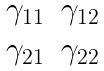<formula> <loc_0><loc_0><loc_500><loc_500>\begin{matrix} \gamma _ { 1 1 } & \gamma _ { 1 2 } \\ \gamma _ { 2 1 } & \gamma _ { 2 2 } \end{matrix}</formula> 